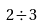Convert formula to latex. <formula><loc_0><loc_0><loc_500><loc_500>2 \div 3</formula> 